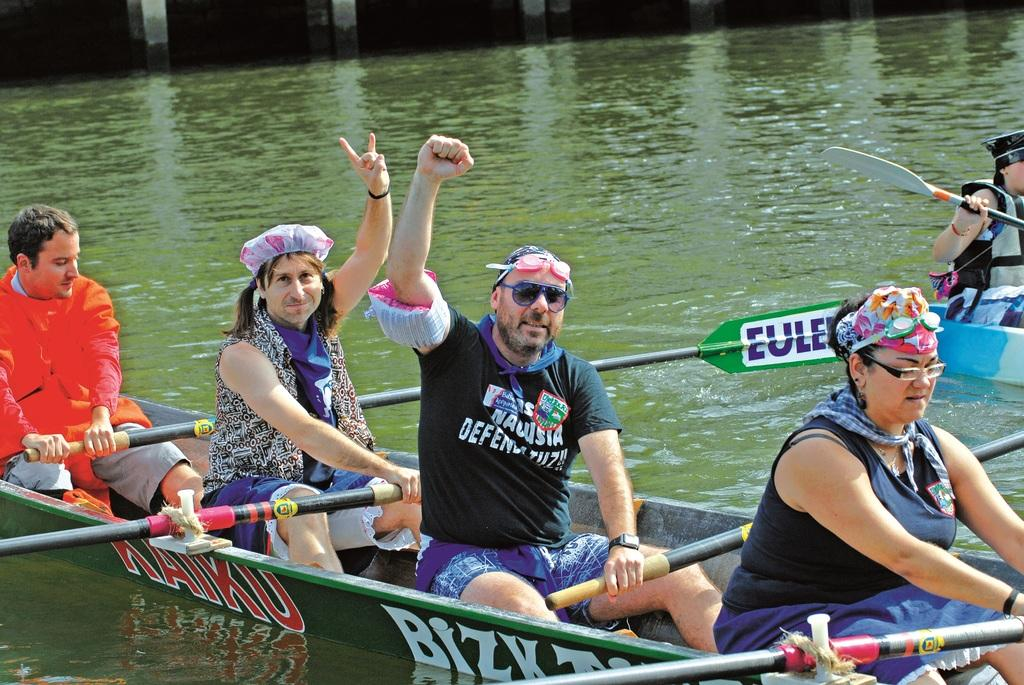How many people are sitting on the bench in the image? There are four persons sitting on a bench in the image. What can be seen on the water in the image? A boat is visible on the lake in the image. Can you describe the person on the boat? There is a person sitting on the boat on the right side. What type of toad can be seen sitting next to the person on the boat? There is no toad present in the image; only the boat and the person sitting on it are visible. 